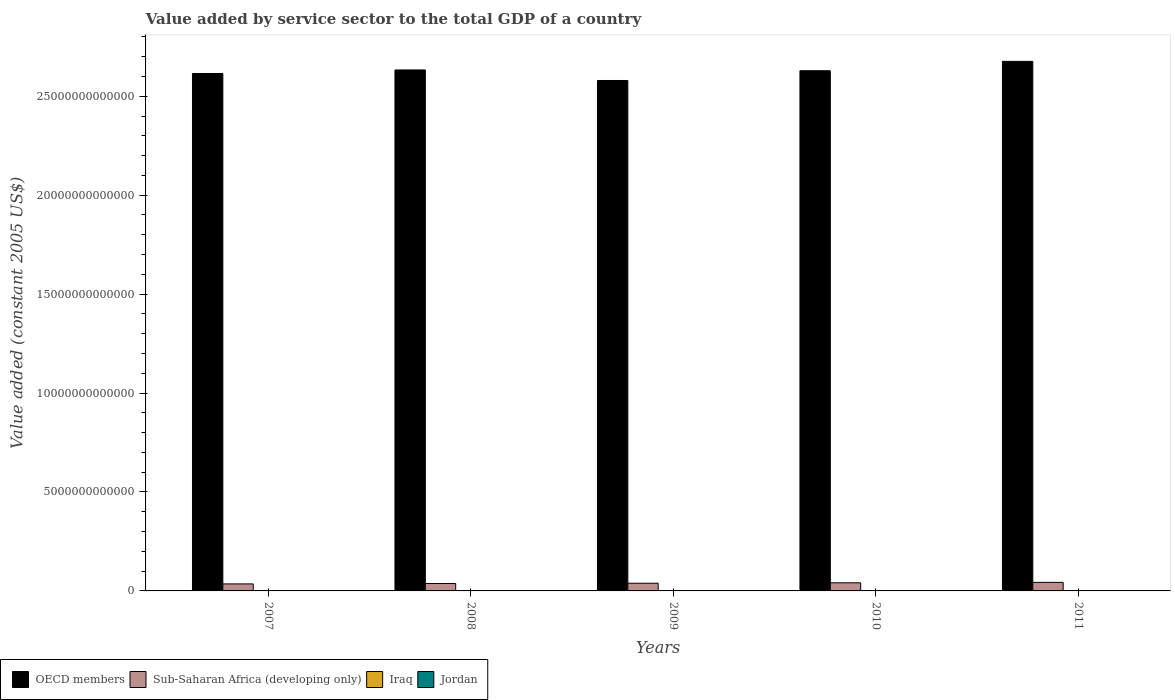Are the number of bars per tick equal to the number of legend labels?
Provide a succinct answer. Yes. Are the number of bars on each tick of the X-axis equal?
Make the answer very short. Yes. How many bars are there on the 4th tick from the right?
Your answer should be compact. 4. What is the label of the 2nd group of bars from the left?
Make the answer very short. 2008. What is the value added by service sector in Jordan in 2009?
Your answer should be very brief. 9.49e+09. Across all years, what is the maximum value added by service sector in OECD members?
Offer a terse response. 2.68e+13. Across all years, what is the minimum value added by service sector in Iraq?
Give a very brief answer. 1.57e+1. In which year was the value added by service sector in OECD members minimum?
Make the answer very short. 2009. What is the total value added by service sector in Iraq in the graph?
Offer a terse response. 8.75e+1. What is the difference between the value added by service sector in OECD members in 2010 and that in 2011?
Your answer should be compact. -4.74e+11. What is the difference between the value added by service sector in Iraq in 2008 and the value added by service sector in Jordan in 2007?
Provide a succinct answer. 7.64e+09. What is the average value added by service sector in Jordan per year?
Provide a succinct answer. 9.53e+09. In the year 2007, what is the difference between the value added by service sector in OECD members and value added by service sector in Sub-Saharan Africa (developing only)?
Your answer should be compact. 2.58e+13. In how many years, is the value added by service sector in Iraq greater than 25000000000000 US$?
Offer a terse response. 0. What is the ratio of the value added by service sector in Jordan in 2009 to that in 2011?
Make the answer very short. 0.93. Is the difference between the value added by service sector in OECD members in 2008 and 2009 greater than the difference between the value added by service sector in Sub-Saharan Africa (developing only) in 2008 and 2009?
Give a very brief answer. Yes. What is the difference between the highest and the second highest value added by service sector in Sub-Saharan Africa (developing only)?
Make the answer very short. 2.12e+1. What is the difference between the highest and the lowest value added by service sector in Jordan?
Keep it short and to the point. 1.46e+09. What does the 1st bar from the left in 2010 represents?
Your response must be concise. OECD members. What does the 2nd bar from the right in 2007 represents?
Make the answer very short. Iraq. How many bars are there?
Provide a short and direct response. 20. What is the difference between two consecutive major ticks on the Y-axis?
Keep it short and to the point. 5.00e+12. Are the values on the major ticks of Y-axis written in scientific E-notation?
Give a very brief answer. No. Where does the legend appear in the graph?
Provide a succinct answer. Bottom left. What is the title of the graph?
Your response must be concise. Value added by service sector to the total GDP of a country. What is the label or title of the X-axis?
Keep it short and to the point. Years. What is the label or title of the Y-axis?
Offer a very short reply. Value added (constant 2005 US$). What is the Value added (constant 2005 US$) of OECD members in 2007?
Make the answer very short. 2.62e+13. What is the Value added (constant 2005 US$) of Sub-Saharan Africa (developing only) in 2007?
Provide a short and direct response. 3.54e+11. What is the Value added (constant 2005 US$) in Iraq in 2007?
Give a very brief answer. 1.57e+1. What is the Value added (constant 2005 US$) in Jordan in 2007?
Make the answer very short. 8.76e+09. What is the Value added (constant 2005 US$) in OECD members in 2008?
Provide a succinct answer. 2.63e+13. What is the Value added (constant 2005 US$) of Sub-Saharan Africa (developing only) in 2008?
Offer a very short reply. 3.75e+11. What is the Value added (constant 2005 US$) of Iraq in 2008?
Give a very brief answer. 1.64e+1. What is the Value added (constant 2005 US$) of Jordan in 2008?
Offer a terse response. 9.28e+09. What is the Value added (constant 2005 US$) of OECD members in 2009?
Give a very brief answer. 2.58e+13. What is the Value added (constant 2005 US$) in Sub-Saharan Africa (developing only) in 2009?
Provide a short and direct response. 3.89e+11. What is the Value added (constant 2005 US$) in Iraq in 2009?
Your response must be concise. 1.71e+1. What is the Value added (constant 2005 US$) of Jordan in 2009?
Make the answer very short. 9.49e+09. What is the Value added (constant 2005 US$) in OECD members in 2010?
Your answer should be compact. 2.63e+13. What is the Value added (constant 2005 US$) of Sub-Saharan Africa (developing only) in 2010?
Your answer should be compact. 4.11e+11. What is the Value added (constant 2005 US$) in Iraq in 2010?
Provide a short and direct response. 1.85e+1. What is the Value added (constant 2005 US$) of Jordan in 2010?
Ensure brevity in your answer.  9.90e+09. What is the Value added (constant 2005 US$) of OECD members in 2011?
Offer a terse response. 2.68e+13. What is the Value added (constant 2005 US$) of Sub-Saharan Africa (developing only) in 2011?
Ensure brevity in your answer.  4.32e+11. What is the Value added (constant 2005 US$) of Iraq in 2011?
Give a very brief answer. 1.98e+1. What is the Value added (constant 2005 US$) of Jordan in 2011?
Give a very brief answer. 1.02e+1. Across all years, what is the maximum Value added (constant 2005 US$) in OECD members?
Keep it short and to the point. 2.68e+13. Across all years, what is the maximum Value added (constant 2005 US$) of Sub-Saharan Africa (developing only)?
Your response must be concise. 4.32e+11. Across all years, what is the maximum Value added (constant 2005 US$) of Iraq?
Offer a terse response. 1.98e+1. Across all years, what is the maximum Value added (constant 2005 US$) of Jordan?
Keep it short and to the point. 1.02e+1. Across all years, what is the minimum Value added (constant 2005 US$) of OECD members?
Your answer should be compact. 2.58e+13. Across all years, what is the minimum Value added (constant 2005 US$) in Sub-Saharan Africa (developing only)?
Keep it short and to the point. 3.54e+11. Across all years, what is the minimum Value added (constant 2005 US$) in Iraq?
Give a very brief answer. 1.57e+1. Across all years, what is the minimum Value added (constant 2005 US$) in Jordan?
Your answer should be very brief. 8.76e+09. What is the total Value added (constant 2005 US$) of OECD members in the graph?
Provide a succinct answer. 1.31e+14. What is the total Value added (constant 2005 US$) of Sub-Saharan Africa (developing only) in the graph?
Offer a very short reply. 1.96e+12. What is the total Value added (constant 2005 US$) of Iraq in the graph?
Give a very brief answer. 8.75e+1. What is the total Value added (constant 2005 US$) of Jordan in the graph?
Make the answer very short. 4.76e+1. What is the difference between the Value added (constant 2005 US$) in OECD members in 2007 and that in 2008?
Give a very brief answer. -1.79e+11. What is the difference between the Value added (constant 2005 US$) in Sub-Saharan Africa (developing only) in 2007 and that in 2008?
Keep it short and to the point. -2.08e+1. What is the difference between the Value added (constant 2005 US$) of Iraq in 2007 and that in 2008?
Your response must be concise. -6.74e+08. What is the difference between the Value added (constant 2005 US$) of Jordan in 2007 and that in 2008?
Keep it short and to the point. -5.17e+08. What is the difference between the Value added (constant 2005 US$) in OECD members in 2007 and that in 2009?
Your response must be concise. 3.54e+11. What is the difference between the Value added (constant 2005 US$) in Sub-Saharan Africa (developing only) in 2007 and that in 2009?
Provide a short and direct response. -3.50e+1. What is the difference between the Value added (constant 2005 US$) of Iraq in 2007 and that in 2009?
Keep it short and to the point. -1.38e+09. What is the difference between the Value added (constant 2005 US$) of Jordan in 2007 and that in 2009?
Give a very brief answer. -7.33e+08. What is the difference between the Value added (constant 2005 US$) in OECD members in 2007 and that in 2010?
Give a very brief answer. -1.40e+11. What is the difference between the Value added (constant 2005 US$) in Sub-Saharan Africa (developing only) in 2007 and that in 2010?
Give a very brief answer. -5.64e+1. What is the difference between the Value added (constant 2005 US$) of Iraq in 2007 and that in 2010?
Your answer should be very brief. -2.75e+09. What is the difference between the Value added (constant 2005 US$) of Jordan in 2007 and that in 2010?
Keep it short and to the point. -1.13e+09. What is the difference between the Value added (constant 2005 US$) of OECD members in 2007 and that in 2011?
Your response must be concise. -6.14e+11. What is the difference between the Value added (constant 2005 US$) of Sub-Saharan Africa (developing only) in 2007 and that in 2011?
Offer a terse response. -7.76e+1. What is the difference between the Value added (constant 2005 US$) in Iraq in 2007 and that in 2011?
Provide a succinct answer. -4.05e+09. What is the difference between the Value added (constant 2005 US$) of Jordan in 2007 and that in 2011?
Your answer should be very brief. -1.46e+09. What is the difference between the Value added (constant 2005 US$) in OECD members in 2008 and that in 2009?
Keep it short and to the point. 5.33e+11. What is the difference between the Value added (constant 2005 US$) in Sub-Saharan Africa (developing only) in 2008 and that in 2009?
Offer a terse response. -1.41e+1. What is the difference between the Value added (constant 2005 US$) in Iraq in 2008 and that in 2009?
Give a very brief answer. -7.08e+08. What is the difference between the Value added (constant 2005 US$) in Jordan in 2008 and that in 2009?
Provide a succinct answer. -2.17e+08. What is the difference between the Value added (constant 2005 US$) in OECD members in 2008 and that in 2010?
Make the answer very short. 3.88e+1. What is the difference between the Value added (constant 2005 US$) of Sub-Saharan Africa (developing only) in 2008 and that in 2010?
Keep it short and to the point. -3.56e+1. What is the difference between the Value added (constant 2005 US$) in Iraq in 2008 and that in 2010?
Provide a succinct answer. -2.08e+09. What is the difference between the Value added (constant 2005 US$) of Jordan in 2008 and that in 2010?
Your answer should be compact. -6.18e+08. What is the difference between the Value added (constant 2005 US$) in OECD members in 2008 and that in 2011?
Provide a short and direct response. -4.35e+11. What is the difference between the Value added (constant 2005 US$) of Sub-Saharan Africa (developing only) in 2008 and that in 2011?
Your answer should be compact. -5.67e+1. What is the difference between the Value added (constant 2005 US$) of Iraq in 2008 and that in 2011?
Make the answer very short. -3.38e+09. What is the difference between the Value added (constant 2005 US$) in Jordan in 2008 and that in 2011?
Make the answer very short. -9.41e+08. What is the difference between the Value added (constant 2005 US$) of OECD members in 2009 and that in 2010?
Your answer should be very brief. -4.94e+11. What is the difference between the Value added (constant 2005 US$) of Sub-Saharan Africa (developing only) in 2009 and that in 2010?
Make the answer very short. -2.14e+1. What is the difference between the Value added (constant 2005 US$) of Iraq in 2009 and that in 2010?
Give a very brief answer. -1.37e+09. What is the difference between the Value added (constant 2005 US$) in Jordan in 2009 and that in 2010?
Keep it short and to the point. -4.02e+08. What is the difference between the Value added (constant 2005 US$) of OECD members in 2009 and that in 2011?
Offer a very short reply. -9.68e+11. What is the difference between the Value added (constant 2005 US$) of Sub-Saharan Africa (developing only) in 2009 and that in 2011?
Ensure brevity in your answer.  -4.26e+1. What is the difference between the Value added (constant 2005 US$) in Iraq in 2009 and that in 2011?
Make the answer very short. -2.67e+09. What is the difference between the Value added (constant 2005 US$) of Jordan in 2009 and that in 2011?
Ensure brevity in your answer.  -7.24e+08. What is the difference between the Value added (constant 2005 US$) in OECD members in 2010 and that in 2011?
Your answer should be compact. -4.74e+11. What is the difference between the Value added (constant 2005 US$) in Sub-Saharan Africa (developing only) in 2010 and that in 2011?
Provide a short and direct response. -2.12e+1. What is the difference between the Value added (constant 2005 US$) of Iraq in 2010 and that in 2011?
Offer a terse response. -1.30e+09. What is the difference between the Value added (constant 2005 US$) of Jordan in 2010 and that in 2011?
Your answer should be very brief. -3.23e+08. What is the difference between the Value added (constant 2005 US$) in OECD members in 2007 and the Value added (constant 2005 US$) in Sub-Saharan Africa (developing only) in 2008?
Give a very brief answer. 2.58e+13. What is the difference between the Value added (constant 2005 US$) of OECD members in 2007 and the Value added (constant 2005 US$) of Iraq in 2008?
Make the answer very short. 2.61e+13. What is the difference between the Value added (constant 2005 US$) in OECD members in 2007 and the Value added (constant 2005 US$) in Jordan in 2008?
Provide a short and direct response. 2.61e+13. What is the difference between the Value added (constant 2005 US$) in Sub-Saharan Africa (developing only) in 2007 and the Value added (constant 2005 US$) in Iraq in 2008?
Make the answer very short. 3.38e+11. What is the difference between the Value added (constant 2005 US$) of Sub-Saharan Africa (developing only) in 2007 and the Value added (constant 2005 US$) of Jordan in 2008?
Make the answer very short. 3.45e+11. What is the difference between the Value added (constant 2005 US$) in Iraq in 2007 and the Value added (constant 2005 US$) in Jordan in 2008?
Your answer should be very brief. 6.45e+09. What is the difference between the Value added (constant 2005 US$) in OECD members in 2007 and the Value added (constant 2005 US$) in Sub-Saharan Africa (developing only) in 2009?
Keep it short and to the point. 2.58e+13. What is the difference between the Value added (constant 2005 US$) in OECD members in 2007 and the Value added (constant 2005 US$) in Iraq in 2009?
Provide a succinct answer. 2.61e+13. What is the difference between the Value added (constant 2005 US$) in OECD members in 2007 and the Value added (constant 2005 US$) in Jordan in 2009?
Offer a terse response. 2.61e+13. What is the difference between the Value added (constant 2005 US$) of Sub-Saharan Africa (developing only) in 2007 and the Value added (constant 2005 US$) of Iraq in 2009?
Your response must be concise. 3.37e+11. What is the difference between the Value added (constant 2005 US$) of Sub-Saharan Africa (developing only) in 2007 and the Value added (constant 2005 US$) of Jordan in 2009?
Provide a short and direct response. 3.45e+11. What is the difference between the Value added (constant 2005 US$) of Iraq in 2007 and the Value added (constant 2005 US$) of Jordan in 2009?
Your answer should be compact. 6.24e+09. What is the difference between the Value added (constant 2005 US$) in OECD members in 2007 and the Value added (constant 2005 US$) in Sub-Saharan Africa (developing only) in 2010?
Your answer should be compact. 2.57e+13. What is the difference between the Value added (constant 2005 US$) in OECD members in 2007 and the Value added (constant 2005 US$) in Iraq in 2010?
Make the answer very short. 2.61e+13. What is the difference between the Value added (constant 2005 US$) of OECD members in 2007 and the Value added (constant 2005 US$) of Jordan in 2010?
Your answer should be very brief. 2.61e+13. What is the difference between the Value added (constant 2005 US$) in Sub-Saharan Africa (developing only) in 2007 and the Value added (constant 2005 US$) in Iraq in 2010?
Provide a succinct answer. 3.36e+11. What is the difference between the Value added (constant 2005 US$) of Sub-Saharan Africa (developing only) in 2007 and the Value added (constant 2005 US$) of Jordan in 2010?
Your answer should be compact. 3.44e+11. What is the difference between the Value added (constant 2005 US$) of Iraq in 2007 and the Value added (constant 2005 US$) of Jordan in 2010?
Provide a short and direct response. 5.83e+09. What is the difference between the Value added (constant 2005 US$) of OECD members in 2007 and the Value added (constant 2005 US$) of Sub-Saharan Africa (developing only) in 2011?
Offer a terse response. 2.57e+13. What is the difference between the Value added (constant 2005 US$) in OECD members in 2007 and the Value added (constant 2005 US$) in Iraq in 2011?
Make the answer very short. 2.61e+13. What is the difference between the Value added (constant 2005 US$) of OECD members in 2007 and the Value added (constant 2005 US$) of Jordan in 2011?
Make the answer very short. 2.61e+13. What is the difference between the Value added (constant 2005 US$) in Sub-Saharan Africa (developing only) in 2007 and the Value added (constant 2005 US$) in Iraq in 2011?
Your answer should be compact. 3.34e+11. What is the difference between the Value added (constant 2005 US$) in Sub-Saharan Africa (developing only) in 2007 and the Value added (constant 2005 US$) in Jordan in 2011?
Your answer should be very brief. 3.44e+11. What is the difference between the Value added (constant 2005 US$) in Iraq in 2007 and the Value added (constant 2005 US$) in Jordan in 2011?
Offer a very short reply. 5.51e+09. What is the difference between the Value added (constant 2005 US$) in OECD members in 2008 and the Value added (constant 2005 US$) in Sub-Saharan Africa (developing only) in 2009?
Your answer should be compact. 2.59e+13. What is the difference between the Value added (constant 2005 US$) in OECD members in 2008 and the Value added (constant 2005 US$) in Iraq in 2009?
Give a very brief answer. 2.63e+13. What is the difference between the Value added (constant 2005 US$) of OECD members in 2008 and the Value added (constant 2005 US$) of Jordan in 2009?
Your answer should be very brief. 2.63e+13. What is the difference between the Value added (constant 2005 US$) in Sub-Saharan Africa (developing only) in 2008 and the Value added (constant 2005 US$) in Iraq in 2009?
Provide a short and direct response. 3.58e+11. What is the difference between the Value added (constant 2005 US$) of Sub-Saharan Africa (developing only) in 2008 and the Value added (constant 2005 US$) of Jordan in 2009?
Provide a short and direct response. 3.65e+11. What is the difference between the Value added (constant 2005 US$) in Iraq in 2008 and the Value added (constant 2005 US$) in Jordan in 2009?
Provide a short and direct response. 6.91e+09. What is the difference between the Value added (constant 2005 US$) in OECD members in 2008 and the Value added (constant 2005 US$) in Sub-Saharan Africa (developing only) in 2010?
Ensure brevity in your answer.  2.59e+13. What is the difference between the Value added (constant 2005 US$) of OECD members in 2008 and the Value added (constant 2005 US$) of Iraq in 2010?
Keep it short and to the point. 2.63e+13. What is the difference between the Value added (constant 2005 US$) in OECD members in 2008 and the Value added (constant 2005 US$) in Jordan in 2010?
Provide a short and direct response. 2.63e+13. What is the difference between the Value added (constant 2005 US$) of Sub-Saharan Africa (developing only) in 2008 and the Value added (constant 2005 US$) of Iraq in 2010?
Your answer should be very brief. 3.56e+11. What is the difference between the Value added (constant 2005 US$) in Sub-Saharan Africa (developing only) in 2008 and the Value added (constant 2005 US$) in Jordan in 2010?
Provide a short and direct response. 3.65e+11. What is the difference between the Value added (constant 2005 US$) in Iraq in 2008 and the Value added (constant 2005 US$) in Jordan in 2010?
Ensure brevity in your answer.  6.51e+09. What is the difference between the Value added (constant 2005 US$) of OECD members in 2008 and the Value added (constant 2005 US$) of Sub-Saharan Africa (developing only) in 2011?
Give a very brief answer. 2.59e+13. What is the difference between the Value added (constant 2005 US$) in OECD members in 2008 and the Value added (constant 2005 US$) in Iraq in 2011?
Keep it short and to the point. 2.63e+13. What is the difference between the Value added (constant 2005 US$) of OECD members in 2008 and the Value added (constant 2005 US$) of Jordan in 2011?
Provide a succinct answer. 2.63e+13. What is the difference between the Value added (constant 2005 US$) of Sub-Saharan Africa (developing only) in 2008 and the Value added (constant 2005 US$) of Iraq in 2011?
Provide a succinct answer. 3.55e+11. What is the difference between the Value added (constant 2005 US$) of Sub-Saharan Africa (developing only) in 2008 and the Value added (constant 2005 US$) of Jordan in 2011?
Provide a succinct answer. 3.65e+11. What is the difference between the Value added (constant 2005 US$) of Iraq in 2008 and the Value added (constant 2005 US$) of Jordan in 2011?
Your response must be concise. 6.19e+09. What is the difference between the Value added (constant 2005 US$) of OECD members in 2009 and the Value added (constant 2005 US$) of Sub-Saharan Africa (developing only) in 2010?
Provide a short and direct response. 2.54e+13. What is the difference between the Value added (constant 2005 US$) of OECD members in 2009 and the Value added (constant 2005 US$) of Iraq in 2010?
Your answer should be compact. 2.58e+13. What is the difference between the Value added (constant 2005 US$) of OECD members in 2009 and the Value added (constant 2005 US$) of Jordan in 2010?
Your response must be concise. 2.58e+13. What is the difference between the Value added (constant 2005 US$) of Sub-Saharan Africa (developing only) in 2009 and the Value added (constant 2005 US$) of Iraq in 2010?
Provide a succinct answer. 3.71e+11. What is the difference between the Value added (constant 2005 US$) in Sub-Saharan Africa (developing only) in 2009 and the Value added (constant 2005 US$) in Jordan in 2010?
Your answer should be compact. 3.79e+11. What is the difference between the Value added (constant 2005 US$) of Iraq in 2009 and the Value added (constant 2005 US$) of Jordan in 2010?
Provide a short and direct response. 7.22e+09. What is the difference between the Value added (constant 2005 US$) of OECD members in 2009 and the Value added (constant 2005 US$) of Sub-Saharan Africa (developing only) in 2011?
Your response must be concise. 2.54e+13. What is the difference between the Value added (constant 2005 US$) in OECD members in 2009 and the Value added (constant 2005 US$) in Iraq in 2011?
Offer a very short reply. 2.58e+13. What is the difference between the Value added (constant 2005 US$) in OECD members in 2009 and the Value added (constant 2005 US$) in Jordan in 2011?
Provide a short and direct response. 2.58e+13. What is the difference between the Value added (constant 2005 US$) of Sub-Saharan Africa (developing only) in 2009 and the Value added (constant 2005 US$) of Iraq in 2011?
Your answer should be compact. 3.69e+11. What is the difference between the Value added (constant 2005 US$) of Sub-Saharan Africa (developing only) in 2009 and the Value added (constant 2005 US$) of Jordan in 2011?
Provide a succinct answer. 3.79e+11. What is the difference between the Value added (constant 2005 US$) of Iraq in 2009 and the Value added (constant 2005 US$) of Jordan in 2011?
Give a very brief answer. 6.89e+09. What is the difference between the Value added (constant 2005 US$) of OECD members in 2010 and the Value added (constant 2005 US$) of Sub-Saharan Africa (developing only) in 2011?
Offer a terse response. 2.59e+13. What is the difference between the Value added (constant 2005 US$) of OECD members in 2010 and the Value added (constant 2005 US$) of Iraq in 2011?
Your response must be concise. 2.63e+13. What is the difference between the Value added (constant 2005 US$) in OECD members in 2010 and the Value added (constant 2005 US$) in Jordan in 2011?
Give a very brief answer. 2.63e+13. What is the difference between the Value added (constant 2005 US$) in Sub-Saharan Africa (developing only) in 2010 and the Value added (constant 2005 US$) in Iraq in 2011?
Your answer should be compact. 3.91e+11. What is the difference between the Value added (constant 2005 US$) of Sub-Saharan Africa (developing only) in 2010 and the Value added (constant 2005 US$) of Jordan in 2011?
Your answer should be very brief. 4.00e+11. What is the difference between the Value added (constant 2005 US$) of Iraq in 2010 and the Value added (constant 2005 US$) of Jordan in 2011?
Keep it short and to the point. 8.27e+09. What is the average Value added (constant 2005 US$) of OECD members per year?
Provide a short and direct response. 2.63e+13. What is the average Value added (constant 2005 US$) in Sub-Saharan Africa (developing only) per year?
Offer a very short reply. 3.92e+11. What is the average Value added (constant 2005 US$) of Iraq per year?
Provide a succinct answer. 1.75e+1. What is the average Value added (constant 2005 US$) in Jordan per year?
Your answer should be very brief. 9.53e+09. In the year 2007, what is the difference between the Value added (constant 2005 US$) of OECD members and Value added (constant 2005 US$) of Sub-Saharan Africa (developing only)?
Provide a succinct answer. 2.58e+13. In the year 2007, what is the difference between the Value added (constant 2005 US$) of OECD members and Value added (constant 2005 US$) of Iraq?
Your answer should be very brief. 2.61e+13. In the year 2007, what is the difference between the Value added (constant 2005 US$) of OECD members and Value added (constant 2005 US$) of Jordan?
Give a very brief answer. 2.61e+13. In the year 2007, what is the difference between the Value added (constant 2005 US$) in Sub-Saharan Africa (developing only) and Value added (constant 2005 US$) in Iraq?
Make the answer very short. 3.38e+11. In the year 2007, what is the difference between the Value added (constant 2005 US$) in Sub-Saharan Africa (developing only) and Value added (constant 2005 US$) in Jordan?
Offer a terse response. 3.45e+11. In the year 2007, what is the difference between the Value added (constant 2005 US$) of Iraq and Value added (constant 2005 US$) of Jordan?
Ensure brevity in your answer.  6.97e+09. In the year 2008, what is the difference between the Value added (constant 2005 US$) of OECD members and Value added (constant 2005 US$) of Sub-Saharan Africa (developing only)?
Your response must be concise. 2.60e+13. In the year 2008, what is the difference between the Value added (constant 2005 US$) of OECD members and Value added (constant 2005 US$) of Iraq?
Provide a short and direct response. 2.63e+13. In the year 2008, what is the difference between the Value added (constant 2005 US$) in OECD members and Value added (constant 2005 US$) in Jordan?
Ensure brevity in your answer.  2.63e+13. In the year 2008, what is the difference between the Value added (constant 2005 US$) in Sub-Saharan Africa (developing only) and Value added (constant 2005 US$) in Iraq?
Ensure brevity in your answer.  3.59e+11. In the year 2008, what is the difference between the Value added (constant 2005 US$) of Sub-Saharan Africa (developing only) and Value added (constant 2005 US$) of Jordan?
Ensure brevity in your answer.  3.66e+11. In the year 2008, what is the difference between the Value added (constant 2005 US$) of Iraq and Value added (constant 2005 US$) of Jordan?
Offer a very short reply. 7.13e+09. In the year 2009, what is the difference between the Value added (constant 2005 US$) in OECD members and Value added (constant 2005 US$) in Sub-Saharan Africa (developing only)?
Your answer should be compact. 2.54e+13. In the year 2009, what is the difference between the Value added (constant 2005 US$) in OECD members and Value added (constant 2005 US$) in Iraq?
Your answer should be very brief. 2.58e+13. In the year 2009, what is the difference between the Value added (constant 2005 US$) in OECD members and Value added (constant 2005 US$) in Jordan?
Provide a succinct answer. 2.58e+13. In the year 2009, what is the difference between the Value added (constant 2005 US$) of Sub-Saharan Africa (developing only) and Value added (constant 2005 US$) of Iraq?
Provide a succinct answer. 3.72e+11. In the year 2009, what is the difference between the Value added (constant 2005 US$) in Sub-Saharan Africa (developing only) and Value added (constant 2005 US$) in Jordan?
Give a very brief answer. 3.80e+11. In the year 2009, what is the difference between the Value added (constant 2005 US$) of Iraq and Value added (constant 2005 US$) of Jordan?
Offer a very short reply. 7.62e+09. In the year 2010, what is the difference between the Value added (constant 2005 US$) of OECD members and Value added (constant 2005 US$) of Sub-Saharan Africa (developing only)?
Provide a short and direct response. 2.59e+13. In the year 2010, what is the difference between the Value added (constant 2005 US$) in OECD members and Value added (constant 2005 US$) in Iraq?
Offer a terse response. 2.63e+13. In the year 2010, what is the difference between the Value added (constant 2005 US$) of OECD members and Value added (constant 2005 US$) of Jordan?
Keep it short and to the point. 2.63e+13. In the year 2010, what is the difference between the Value added (constant 2005 US$) of Sub-Saharan Africa (developing only) and Value added (constant 2005 US$) of Iraq?
Offer a very short reply. 3.92e+11. In the year 2010, what is the difference between the Value added (constant 2005 US$) of Sub-Saharan Africa (developing only) and Value added (constant 2005 US$) of Jordan?
Make the answer very short. 4.01e+11. In the year 2010, what is the difference between the Value added (constant 2005 US$) in Iraq and Value added (constant 2005 US$) in Jordan?
Keep it short and to the point. 8.59e+09. In the year 2011, what is the difference between the Value added (constant 2005 US$) in OECD members and Value added (constant 2005 US$) in Sub-Saharan Africa (developing only)?
Make the answer very short. 2.63e+13. In the year 2011, what is the difference between the Value added (constant 2005 US$) in OECD members and Value added (constant 2005 US$) in Iraq?
Provide a succinct answer. 2.67e+13. In the year 2011, what is the difference between the Value added (constant 2005 US$) of OECD members and Value added (constant 2005 US$) of Jordan?
Keep it short and to the point. 2.68e+13. In the year 2011, what is the difference between the Value added (constant 2005 US$) of Sub-Saharan Africa (developing only) and Value added (constant 2005 US$) of Iraq?
Your answer should be very brief. 4.12e+11. In the year 2011, what is the difference between the Value added (constant 2005 US$) of Sub-Saharan Africa (developing only) and Value added (constant 2005 US$) of Jordan?
Your answer should be very brief. 4.21e+11. In the year 2011, what is the difference between the Value added (constant 2005 US$) of Iraq and Value added (constant 2005 US$) of Jordan?
Make the answer very short. 9.57e+09. What is the ratio of the Value added (constant 2005 US$) of Sub-Saharan Africa (developing only) in 2007 to that in 2008?
Keep it short and to the point. 0.94. What is the ratio of the Value added (constant 2005 US$) in Iraq in 2007 to that in 2008?
Make the answer very short. 0.96. What is the ratio of the Value added (constant 2005 US$) of Jordan in 2007 to that in 2008?
Offer a terse response. 0.94. What is the ratio of the Value added (constant 2005 US$) in OECD members in 2007 to that in 2009?
Keep it short and to the point. 1.01. What is the ratio of the Value added (constant 2005 US$) of Sub-Saharan Africa (developing only) in 2007 to that in 2009?
Offer a terse response. 0.91. What is the ratio of the Value added (constant 2005 US$) of Iraq in 2007 to that in 2009?
Offer a very short reply. 0.92. What is the ratio of the Value added (constant 2005 US$) of Jordan in 2007 to that in 2009?
Your response must be concise. 0.92. What is the ratio of the Value added (constant 2005 US$) in OECD members in 2007 to that in 2010?
Keep it short and to the point. 0.99. What is the ratio of the Value added (constant 2005 US$) of Sub-Saharan Africa (developing only) in 2007 to that in 2010?
Keep it short and to the point. 0.86. What is the ratio of the Value added (constant 2005 US$) in Iraq in 2007 to that in 2010?
Offer a terse response. 0.85. What is the ratio of the Value added (constant 2005 US$) of Jordan in 2007 to that in 2010?
Provide a succinct answer. 0.89. What is the ratio of the Value added (constant 2005 US$) of OECD members in 2007 to that in 2011?
Offer a very short reply. 0.98. What is the ratio of the Value added (constant 2005 US$) of Sub-Saharan Africa (developing only) in 2007 to that in 2011?
Provide a short and direct response. 0.82. What is the ratio of the Value added (constant 2005 US$) in Iraq in 2007 to that in 2011?
Ensure brevity in your answer.  0.8. What is the ratio of the Value added (constant 2005 US$) in Jordan in 2007 to that in 2011?
Provide a short and direct response. 0.86. What is the ratio of the Value added (constant 2005 US$) in OECD members in 2008 to that in 2009?
Give a very brief answer. 1.02. What is the ratio of the Value added (constant 2005 US$) of Sub-Saharan Africa (developing only) in 2008 to that in 2009?
Offer a terse response. 0.96. What is the ratio of the Value added (constant 2005 US$) of Iraq in 2008 to that in 2009?
Keep it short and to the point. 0.96. What is the ratio of the Value added (constant 2005 US$) in Jordan in 2008 to that in 2009?
Ensure brevity in your answer.  0.98. What is the ratio of the Value added (constant 2005 US$) in OECD members in 2008 to that in 2010?
Your response must be concise. 1. What is the ratio of the Value added (constant 2005 US$) in Sub-Saharan Africa (developing only) in 2008 to that in 2010?
Keep it short and to the point. 0.91. What is the ratio of the Value added (constant 2005 US$) of Iraq in 2008 to that in 2010?
Give a very brief answer. 0.89. What is the ratio of the Value added (constant 2005 US$) of OECD members in 2008 to that in 2011?
Your answer should be very brief. 0.98. What is the ratio of the Value added (constant 2005 US$) of Sub-Saharan Africa (developing only) in 2008 to that in 2011?
Provide a succinct answer. 0.87. What is the ratio of the Value added (constant 2005 US$) of Iraq in 2008 to that in 2011?
Offer a terse response. 0.83. What is the ratio of the Value added (constant 2005 US$) in Jordan in 2008 to that in 2011?
Your answer should be very brief. 0.91. What is the ratio of the Value added (constant 2005 US$) in OECD members in 2009 to that in 2010?
Provide a succinct answer. 0.98. What is the ratio of the Value added (constant 2005 US$) in Sub-Saharan Africa (developing only) in 2009 to that in 2010?
Ensure brevity in your answer.  0.95. What is the ratio of the Value added (constant 2005 US$) of Iraq in 2009 to that in 2010?
Your answer should be very brief. 0.93. What is the ratio of the Value added (constant 2005 US$) in Jordan in 2009 to that in 2010?
Your response must be concise. 0.96. What is the ratio of the Value added (constant 2005 US$) of OECD members in 2009 to that in 2011?
Offer a terse response. 0.96. What is the ratio of the Value added (constant 2005 US$) of Sub-Saharan Africa (developing only) in 2009 to that in 2011?
Give a very brief answer. 0.9. What is the ratio of the Value added (constant 2005 US$) in Iraq in 2009 to that in 2011?
Ensure brevity in your answer.  0.86. What is the ratio of the Value added (constant 2005 US$) of Jordan in 2009 to that in 2011?
Ensure brevity in your answer.  0.93. What is the ratio of the Value added (constant 2005 US$) of OECD members in 2010 to that in 2011?
Keep it short and to the point. 0.98. What is the ratio of the Value added (constant 2005 US$) in Sub-Saharan Africa (developing only) in 2010 to that in 2011?
Give a very brief answer. 0.95. What is the ratio of the Value added (constant 2005 US$) of Iraq in 2010 to that in 2011?
Provide a succinct answer. 0.93. What is the ratio of the Value added (constant 2005 US$) of Jordan in 2010 to that in 2011?
Ensure brevity in your answer.  0.97. What is the difference between the highest and the second highest Value added (constant 2005 US$) of OECD members?
Keep it short and to the point. 4.35e+11. What is the difference between the highest and the second highest Value added (constant 2005 US$) in Sub-Saharan Africa (developing only)?
Your answer should be very brief. 2.12e+1. What is the difference between the highest and the second highest Value added (constant 2005 US$) of Iraq?
Keep it short and to the point. 1.30e+09. What is the difference between the highest and the second highest Value added (constant 2005 US$) in Jordan?
Provide a succinct answer. 3.23e+08. What is the difference between the highest and the lowest Value added (constant 2005 US$) of OECD members?
Make the answer very short. 9.68e+11. What is the difference between the highest and the lowest Value added (constant 2005 US$) in Sub-Saharan Africa (developing only)?
Provide a short and direct response. 7.76e+1. What is the difference between the highest and the lowest Value added (constant 2005 US$) in Iraq?
Ensure brevity in your answer.  4.05e+09. What is the difference between the highest and the lowest Value added (constant 2005 US$) in Jordan?
Your answer should be very brief. 1.46e+09. 